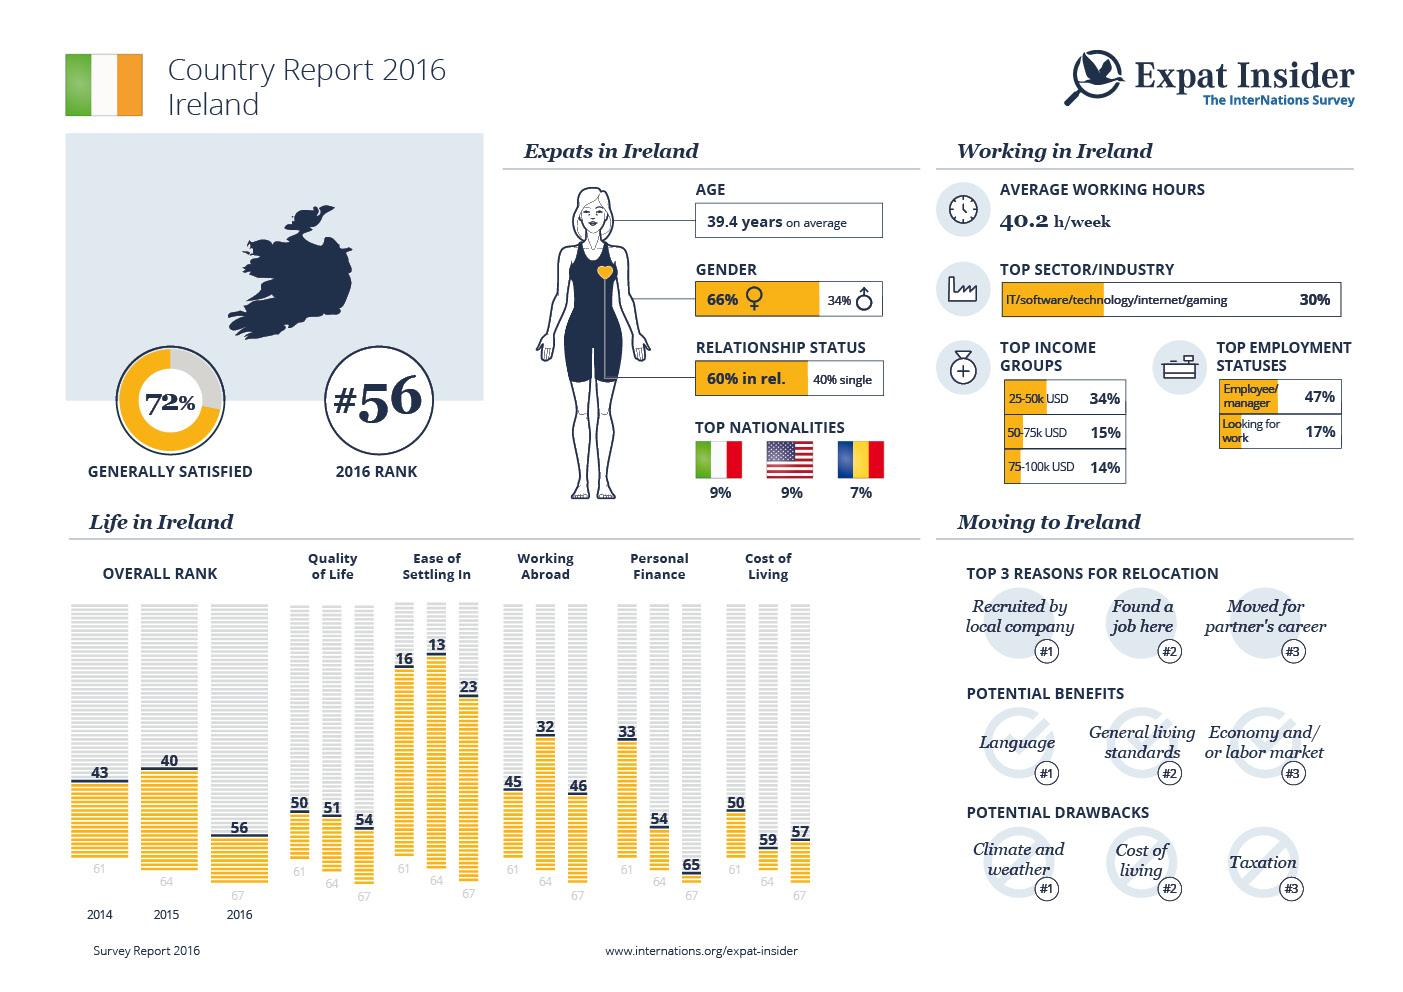Specify some key components in this picture. The second most significant drawback in moving to Ireland, according to the survey, is the cost of living. Approximately 29% of the population has a salary between 50,000 and 100,000 USD. According to the given information, 63% of the people have a salary between 25K and 100K. The most common salary range in Ireland is between 25,000 and 50,000 USD. The second most significant benefit of moving to Ireland, according to the survey, is the general living standard. 